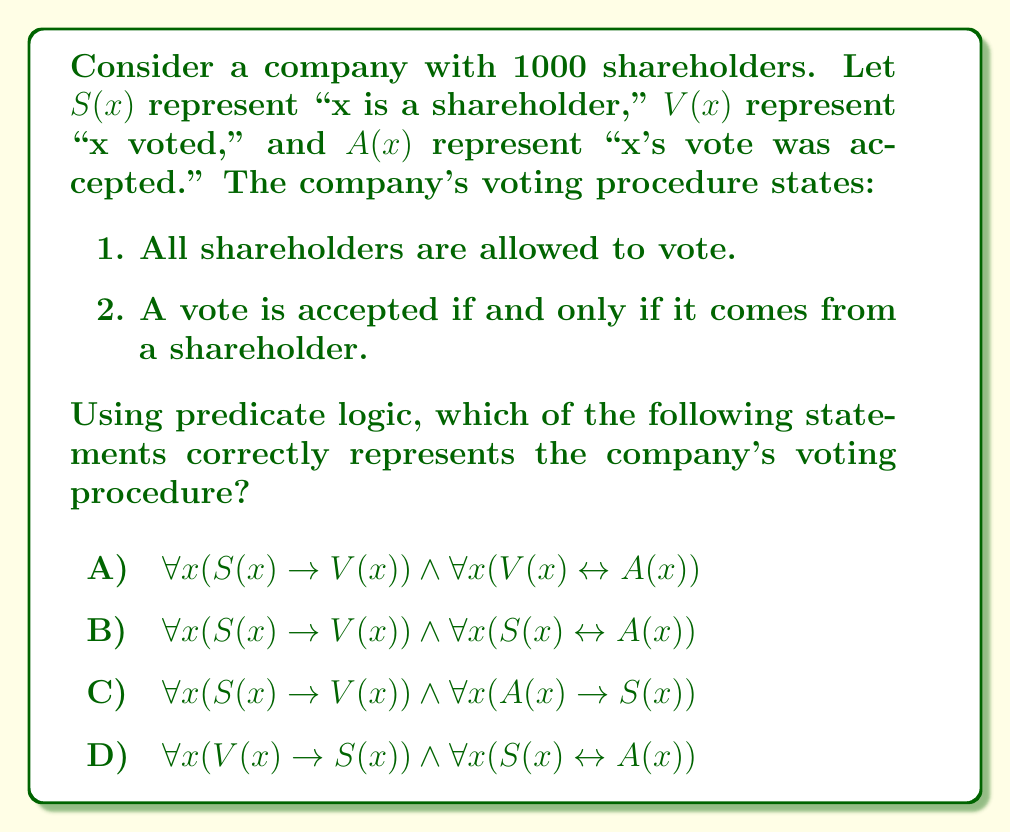Can you answer this question? Let's analyze each statement step-by-step:

1. The first part of the voting procedure states that all shareholders are allowed to vote. This is represented by:
   $\forall x (S(x) \rightarrow V(x))$
   This means "for all x, if x is a shareholder, then x is allowed to vote."

2. The second part states that a vote is accepted if and only if it comes from a shareholder. This is represented by:
   $\forall x (S(x) \leftrightarrow A(x))$
   This means "for all x, x is a shareholder if and only if x's vote is accepted."

Now, let's examine each option:

A) $\forall x (S(x) \rightarrow V(x)) \land \forall x (V(x) \leftrightarrow A(x))$
   The first part is correct, but the second part implies that all votes are accepted, which is not true.

B) $\forall x (S(x) \rightarrow V(x)) \land \forall x (S(x) \leftrightarrow A(x))$
   This option correctly represents both parts of the voting procedure.

C) $\forall x (S(x) \rightarrow V(x)) \land \forall x (A(x) \rightarrow S(x))$
   The first part is correct, but the second part only states that if a vote is accepted, it must be from a shareholder. It doesn't guarantee that all shareholder votes are accepted.

D) $\forall x (V(x) \rightarrow S(x)) \land \forall x (S(x) \leftrightarrow A(x))$
   The first part incorrectly states that only shareholders can vote, which is not specified in the procedure. The second part is correct.

Therefore, option B correctly represents the company's voting procedure using predicate logic.
Answer: B 